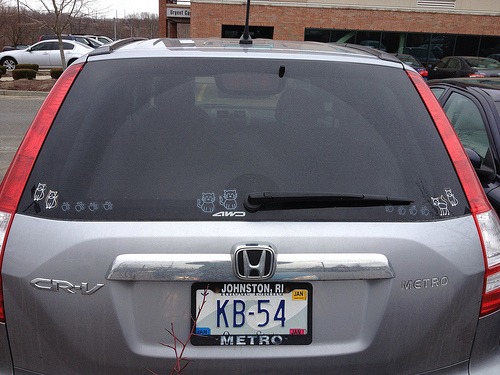<image>
Can you confirm if the building is above the car? No. The building is not positioned above the car. The vertical arrangement shows a different relationship. 